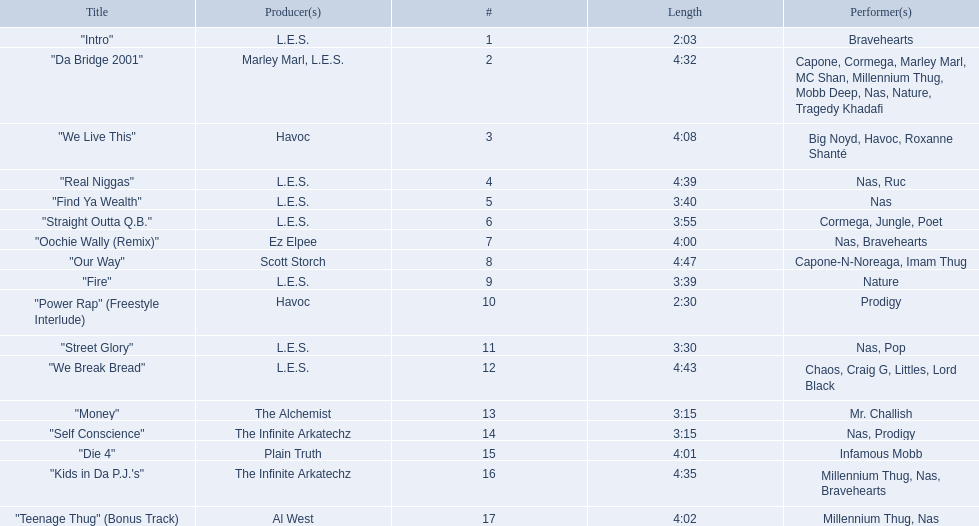How long is each song? 2:03, 4:32, 4:08, 4:39, 3:40, 3:55, 4:00, 4:47, 3:39, 2:30, 3:30, 4:43, 3:15, 3:15, 4:01, 4:35, 4:02. Of those, which length is the shortest? 2:03. 